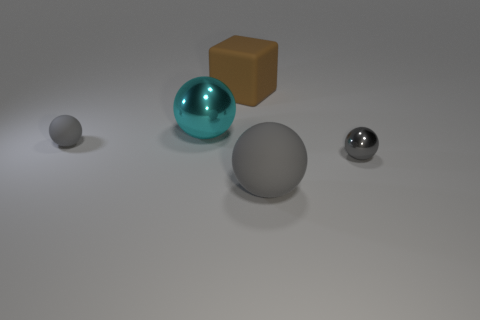What is the material of the small gray object to the right of the gray matte sphere that is behind the matte object in front of the small gray metal object?
Your response must be concise. Metal. What is the material of the big cyan sphere?
Offer a very short reply. Metal. There is a tiny thing that is in front of the tiny gray rubber sphere; does it have the same color as the matte sphere that is on the right side of the brown rubber object?
Offer a terse response. Yes. Is the number of matte objects greater than the number of tiny brown metallic objects?
Ensure brevity in your answer.  Yes. What number of metal objects are the same color as the tiny shiny ball?
Keep it short and to the point. 0. The tiny rubber object that is the same shape as the big cyan object is what color?
Ensure brevity in your answer.  Gray. There is a thing that is behind the big gray object and right of the brown rubber thing; what is its material?
Your answer should be compact. Metal. Is the material of the large object that is right of the big brown object the same as the tiny gray object right of the large cyan sphere?
Ensure brevity in your answer.  No. What is the size of the gray shiny thing?
Give a very brief answer. Small. The cyan thing that is the same shape as the big gray object is what size?
Keep it short and to the point. Large. 